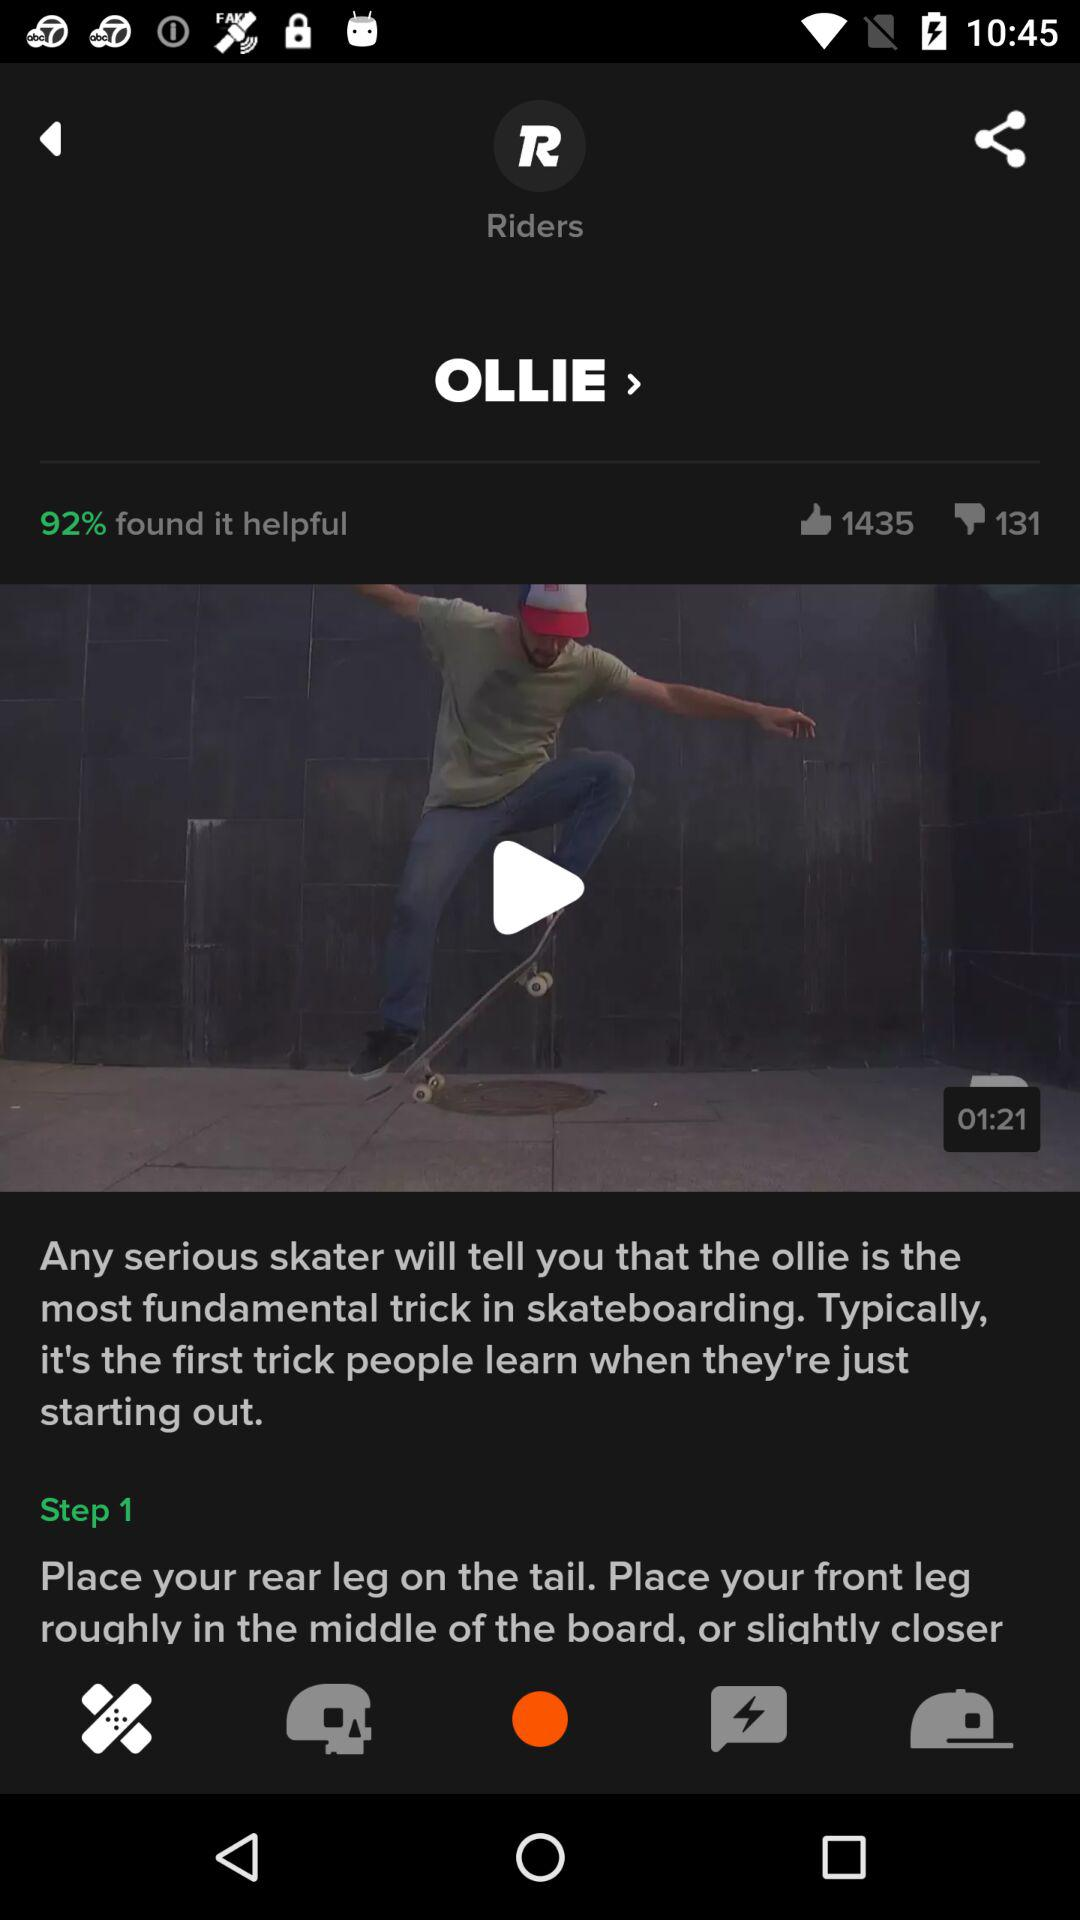What is the duration of the video? The duration of the video is 1 minute 21 seconds. 